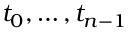Convert formula to latex. <formula><loc_0><loc_0><loc_500><loc_500>t _ { 0 } , \dots , t _ { n - 1 }</formula> 